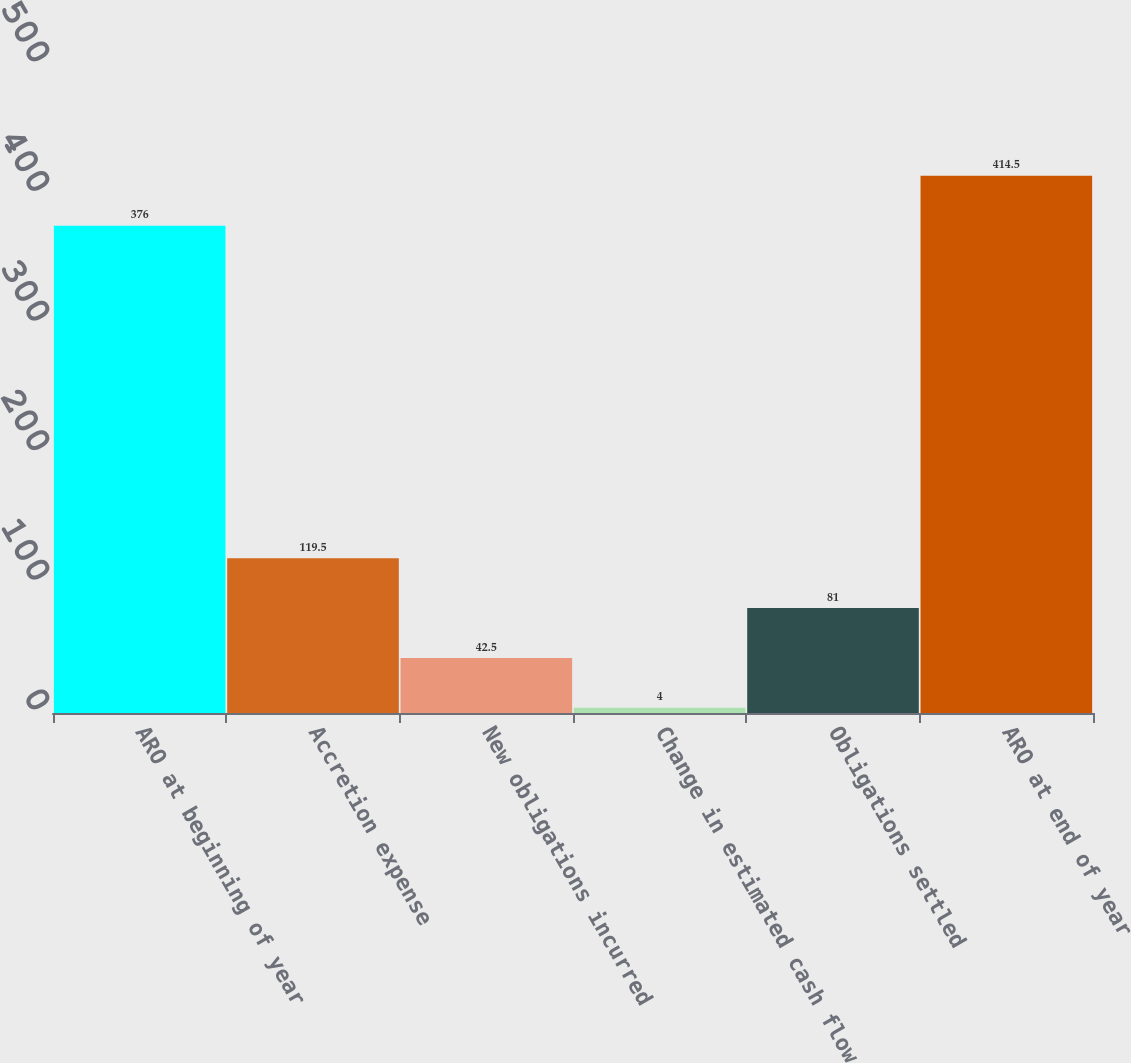<chart> <loc_0><loc_0><loc_500><loc_500><bar_chart><fcel>ARO at beginning of year<fcel>Accretion expense<fcel>New obligations incurred<fcel>Change in estimated cash flow<fcel>Obligations settled<fcel>ARO at end of year<nl><fcel>376<fcel>119.5<fcel>42.5<fcel>4<fcel>81<fcel>414.5<nl></chart> 